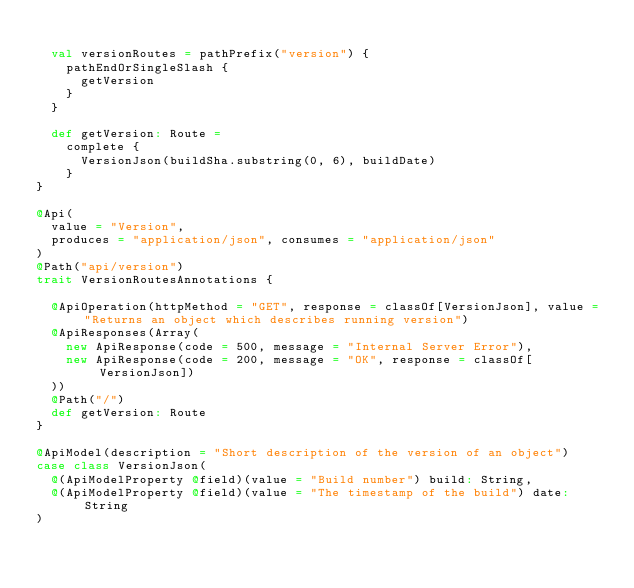<code> <loc_0><loc_0><loc_500><loc_500><_Scala_>
  val versionRoutes = pathPrefix("version") {
    pathEndOrSingleSlash {
      getVersion
    }
  }

  def getVersion: Route =
    complete {
      VersionJson(buildSha.substring(0, 6), buildDate)
    }
}

@Api(
  value = "Version",
  produces = "application/json", consumes = "application/json"
)
@Path("api/version")
trait VersionRoutesAnnotations {

  @ApiOperation(httpMethod = "GET", response = classOf[VersionJson], value = "Returns an object which describes running version")
  @ApiResponses(Array(
    new ApiResponse(code = 500, message = "Internal Server Error"),
    new ApiResponse(code = 200, message = "OK", response = classOf[VersionJson])
  ))
  @Path("/")
  def getVersion: Route
}

@ApiModel(description = "Short description of the version of an object")
case class VersionJson(
  @(ApiModelProperty @field)(value = "Build number") build: String,
  @(ApiModelProperty @field)(value = "The timestamp of the build") date: String
)
</code> 